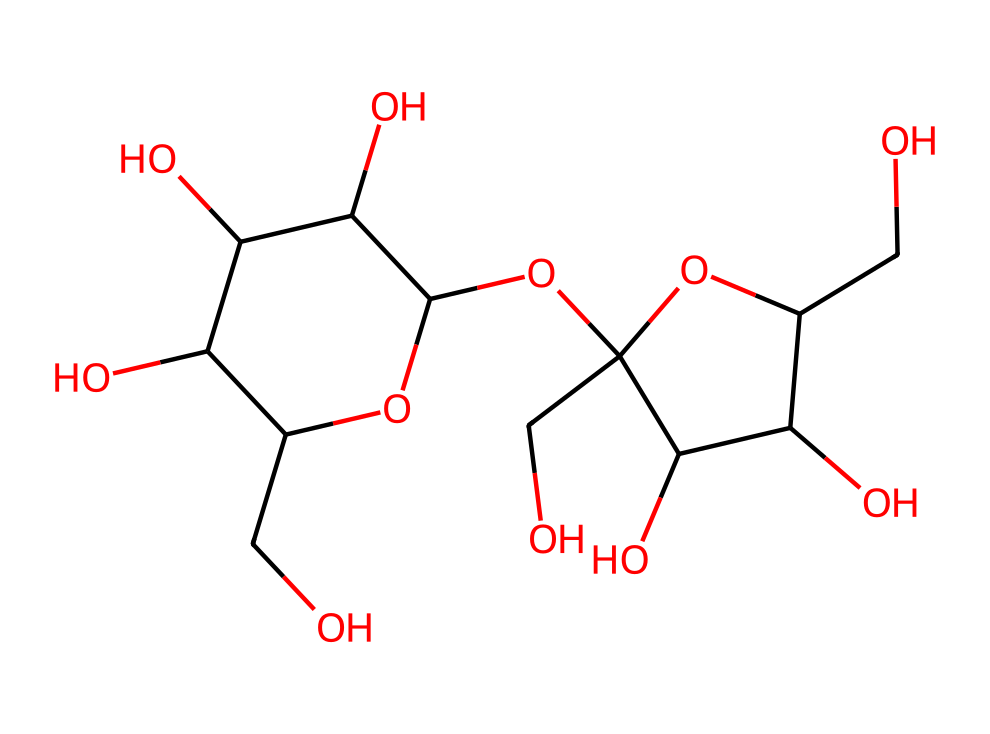What is the molecular formula of this chemical? To determine the molecular formula, we count the number of each type of atom in the chemical structure. By analyzing the SMILES provided, we find a total of 12 carbon atoms, 22 hydrogen atoms, and 11 oxygen atoms, resulting in the molecular formula C12H22O11.
Answer: C12H22O11 How many rings are present in this molecule? By examining the chemical structure represented by the SMILES, we identify two distinct cyclic structures (rings). These rings are indicated by the numbers in the SMILES, linking the atoms to form cycles. Therefore, the molecule contains 2 rings.
Answer: 2 What type of carbohydrate is represented here? Analyzing the structural characteristics, we can identify that this molecule is a disaccharide since it is formed by the glycosidic bond between two monosaccharides (glucose and fructose, in this case). This categorizes the carbohydrate as sucrose, which is a common disaccharide.
Answer: disaccharide How many hydroxyl (-OH) groups are present? By inspecting the structure, we locate the functional groups, particularly the hydroxyl groups, which are typically represented as -OH in carbohydrates. Counting these groups, we find that there are 11 hydroxyl groups present in the molecule.
Answer: 11 Which part of this chemical contributes to its sweet taste? The sweet taste of sucrose is primarily attributed to the specific arrangement of its glucose and fructose units. This combination activates the sweet receptors on the taste buds, making sucrose recognized as a sweet carbohydrate.
Answer: glucose and fructose What is the significance of sucrose in food preservation? Sucrose acts as a preservative by lowering the water activity in foods, which inhibits the growth of microorganisms that cause spoilage. Its high solubility and stability make it valuable in food preservation methods.
Answer: lowers water activity 